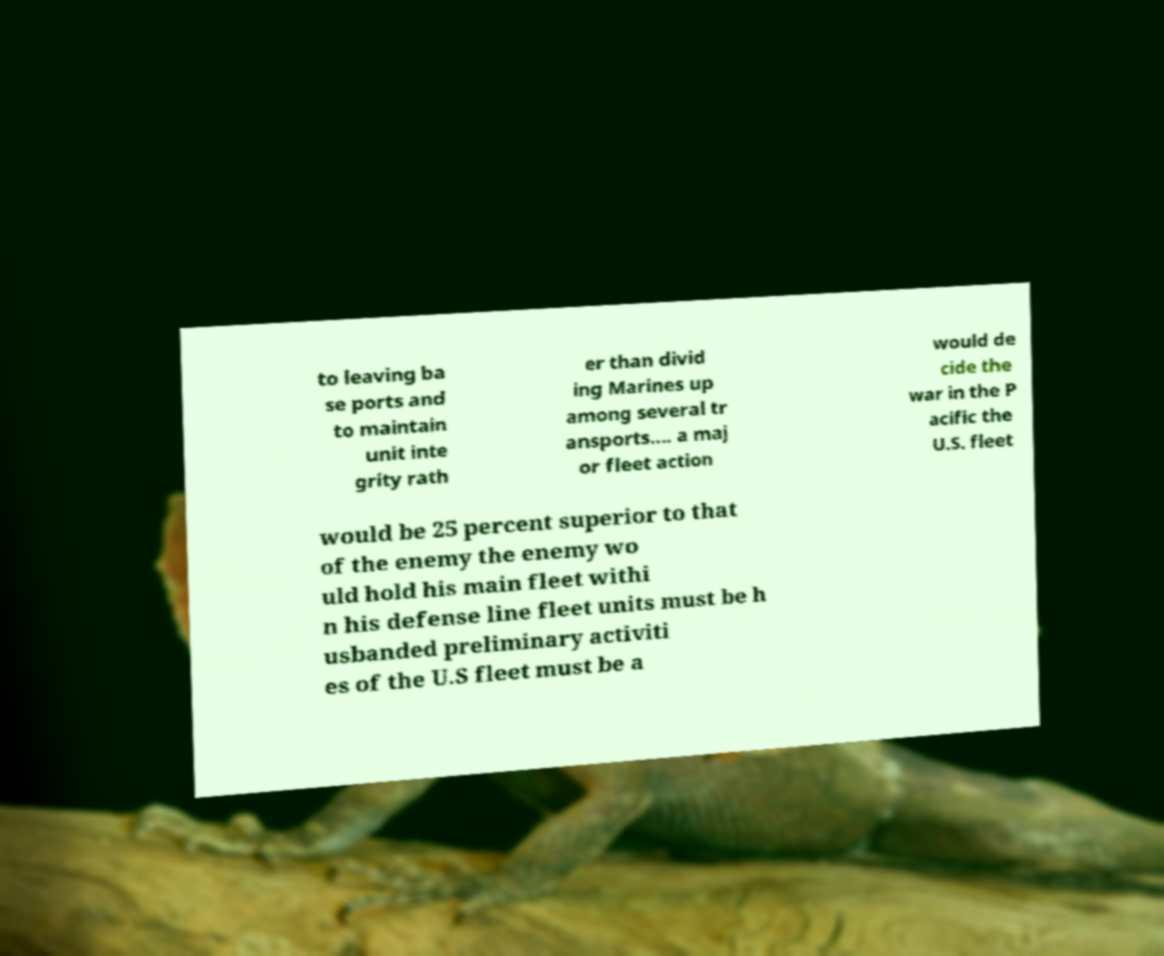Can you accurately transcribe the text from the provided image for me? to leaving ba se ports and to maintain unit inte grity rath er than divid ing Marines up among several tr ansports.... a maj or fleet action would de cide the war in the P acific the U.S. fleet would be 25 percent superior to that of the enemy the enemy wo uld hold his main fleet withi n his defense line fleet units must be h usbanded preliminary activiti es of the U.S fleet must be a 